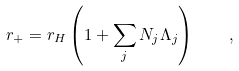<formula> <loc_0><loc_0><loc_500><loc_500>r _ { + } = r _ { H } \left ( 1 + \sum _ { j } N _ { j } \Lambda _ { j } \right ) \quad ,</formula> 